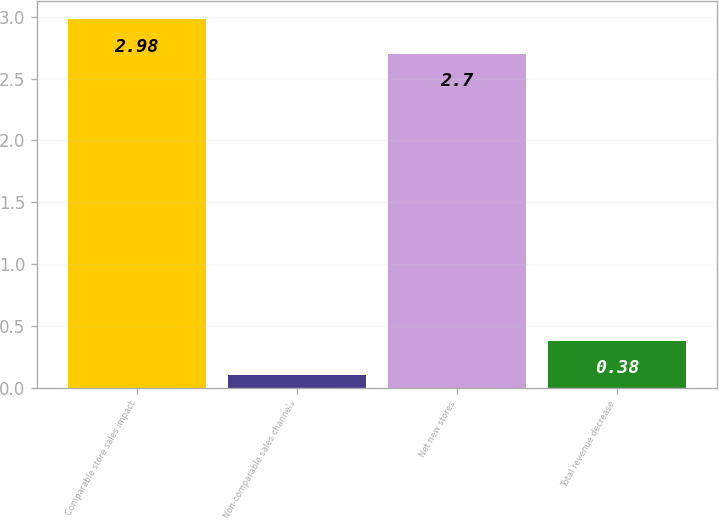<chart> <loc_0><loc_0><loc_500><loc_500><bar_chart><fcel>Comparable store sales impact<fcel>Non-comparable sales channels<fcel>Net new stores<fcel>Total revenue decrease<nl><fcel>2.98<fcel>0.1<fcel>2.7<fcel>0.38<nl></chart> 